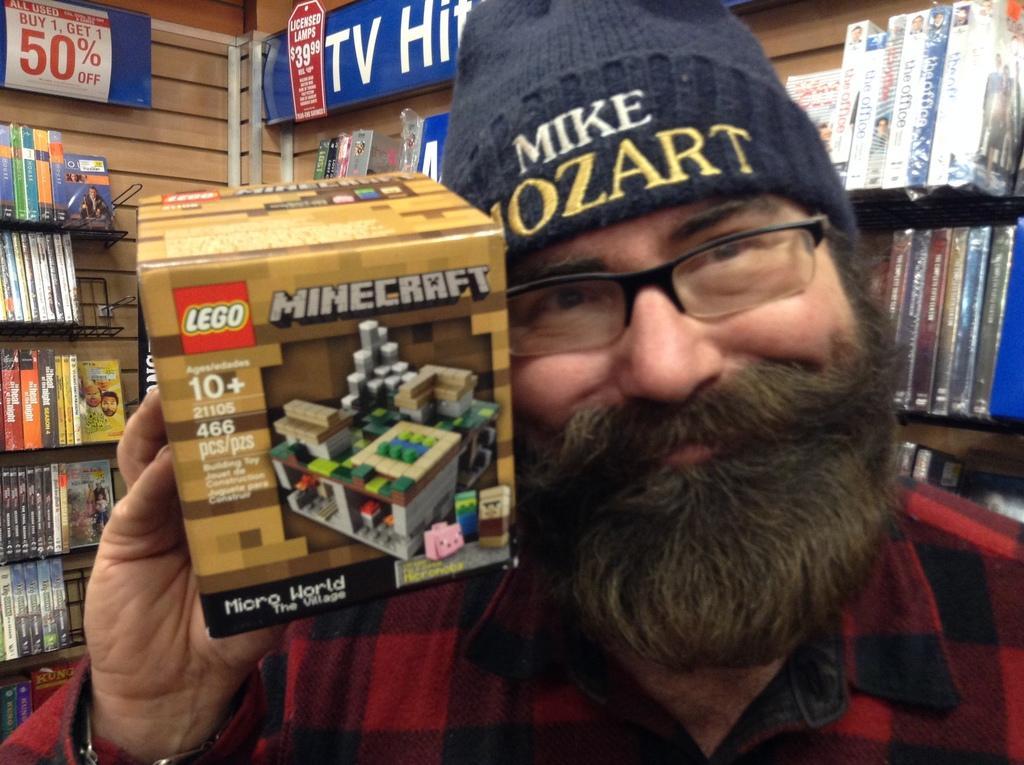How would you summarize this image in a sentence or two? In this image we can see a man holding a box of Lego minecraft. He is wearing a specs and a cap. In the background we can see book shelf with the number of books. We can also see a poster of Buy 1 Get 1 50% off. 